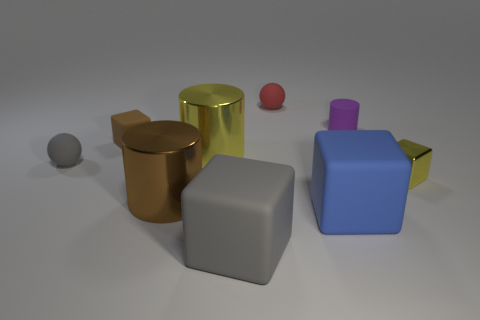Does the small yellow object have the same shape as the purple object?
Give a very brief answer. No. There is a brown thing to the left of the large metal cylinder in front of the tiny block right of the purple matte object; what is its size?
Make the answer very short. Small. There is a gray object that is the same shape as the small red object; what is it made of?
Ensure brevity in your answer.  Rubber. Is there any other thing that is the same size as the blue object?
Provide a short and direct response. Yes. There is a shiny cylinder that is to the right of the big brown shiny object in front of the small purple object; what is its size?
Keep it short and to the point. Large. The tiny cylinder has what color?
Offer a very short reply. Purple. There is a small cube left of the tiny yellow block; how many small yellow things are left of it?
Offer a terse response. 0. There is a yellow object on the left side of the tiny yellow block; are there any metal things behind it?
Your answer should be compact. No. There is a gray sphere; are there any gray matte balls to the right of it?
Keep it short and to the point. No. Do the tiny gray object behind the yellow cube and the large blue object have the same shape?
Your response must be concise. No. 